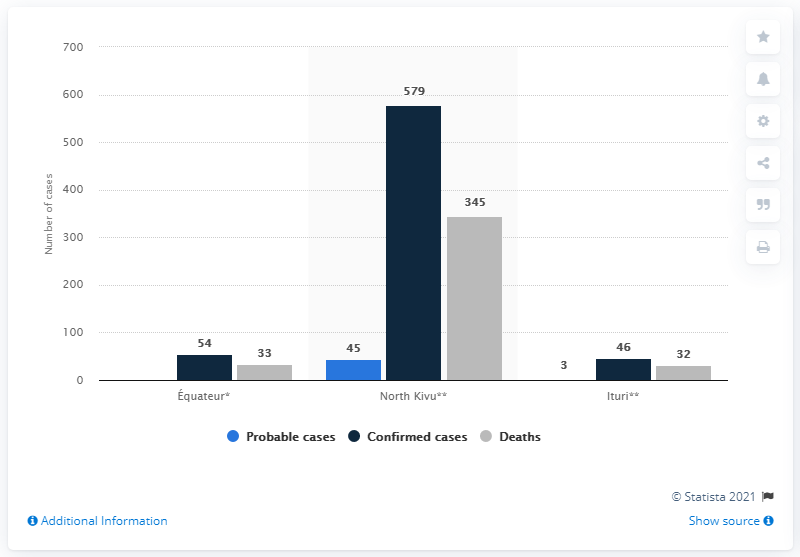Highlight a few significant elements in this photo. During the outbreak in North Kivu, a total of 345 individuals lost their lives due to Ebola. To date, a total of 579 cases of Ebola have been confirmed in North Kivu. 